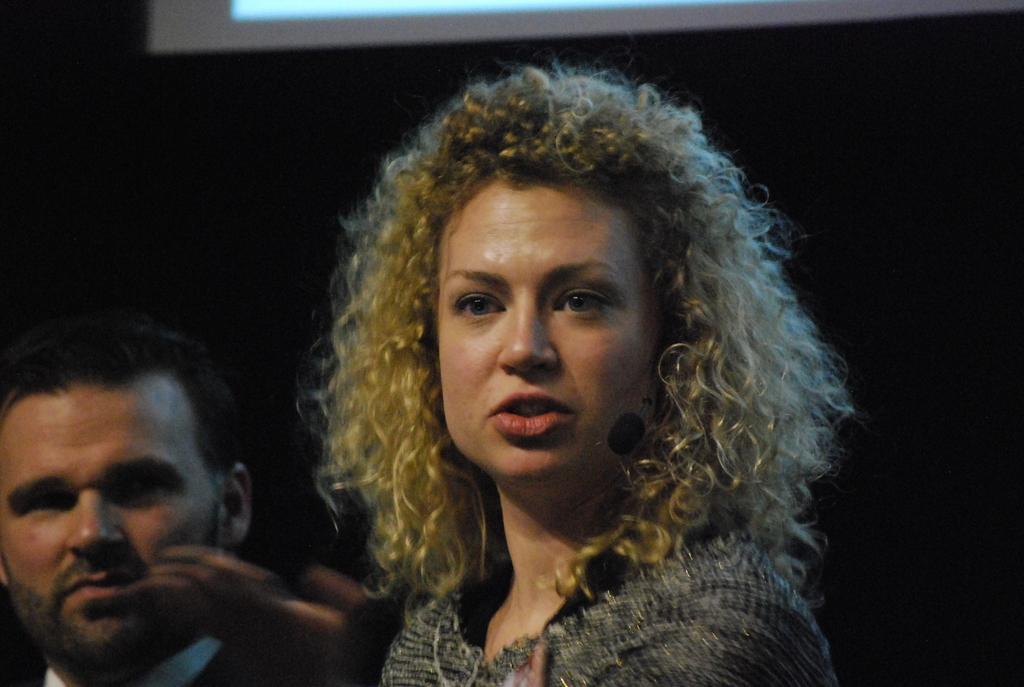How would you summarize this image in a sentence or two? In this picture we can see a woman and a man. Background is black in color. 